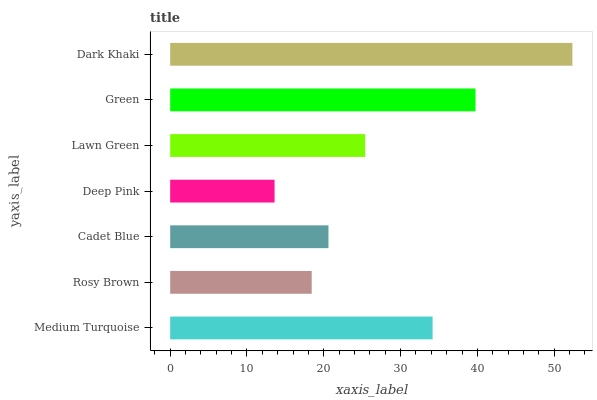Is Deep Pink the minimum?
Answer yes or no. Yes. Is Dark Khaki the maximum?
Answer yes or no. Yes. Is Rosy Brown the minimum?
Answer yes or no. No. Is Rosy Brown the maximum?
Answer yes or no. No. Is Medium Turquoise greater than Rosy Brown?
Answer yes or no. Yes. Is Rosy Brown less than Medium Turquoise?
Answer yes or no. Yes. Is Rosy Brown greater than Medium Turquoise?
Answer yes or no. No. Is Medium Turquoise less than Rosy Brown?
Answer yes or no. No. Is Lawn Green the high median?
Answer yes or no. Yes. Is Lawn Green the low median?
Answer yes or no. Yes. Is Green the high median?
Answer yes or no. No. Is Rosy Brown the low median?
Answer yes or no. No. 